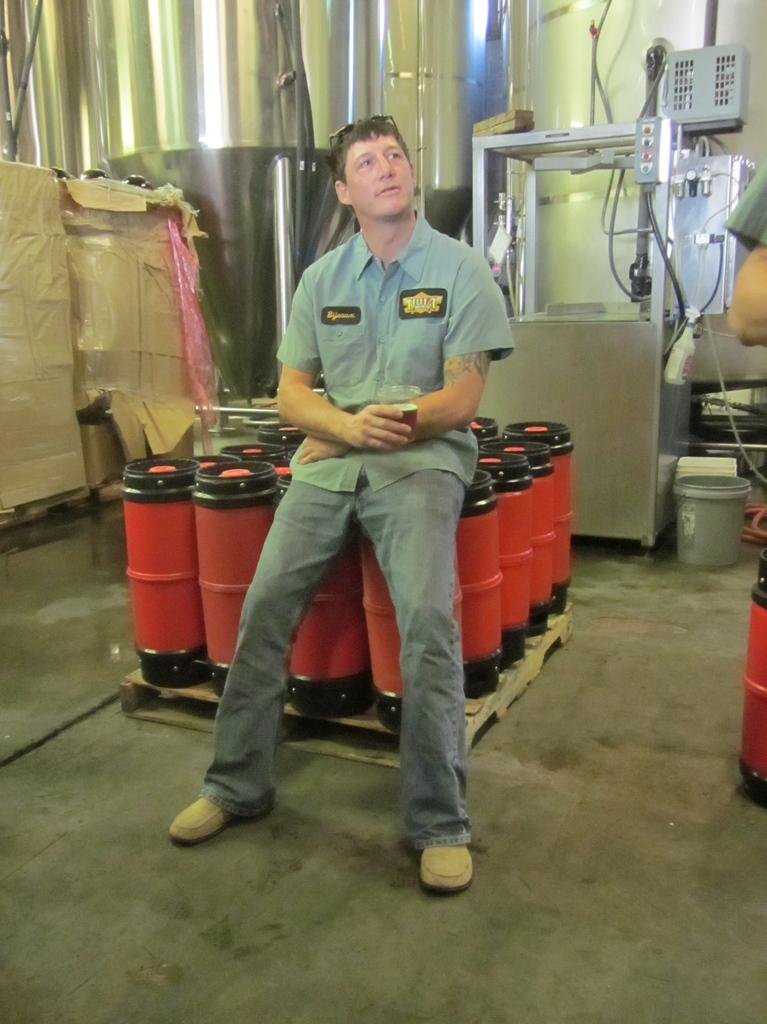What is the man in the image doing? The man is sitting on a drum kit in the image. What can be seen on the left side of the image? There are boxes on the left side of the image. What is visible in the background of the image? There is a wall and equipment visible in the background of the image. What type of calculator is the man using while playing the drums in the image? There is no calculator present in the image, and the man is not using any calculator while playing the drums. 